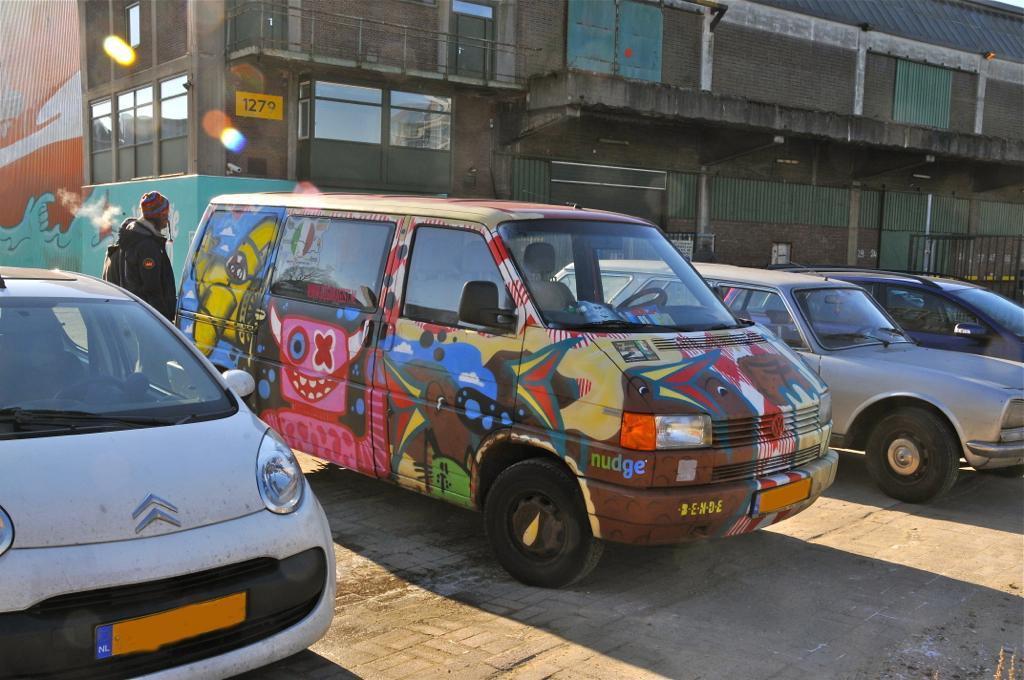Please provide a concise description of this image. In this image there are vehicles on the road and on the left side a man is standing at the vehicle. In the background there is a building, fences, windows, roof and on the left side there are paintings on the wall. 